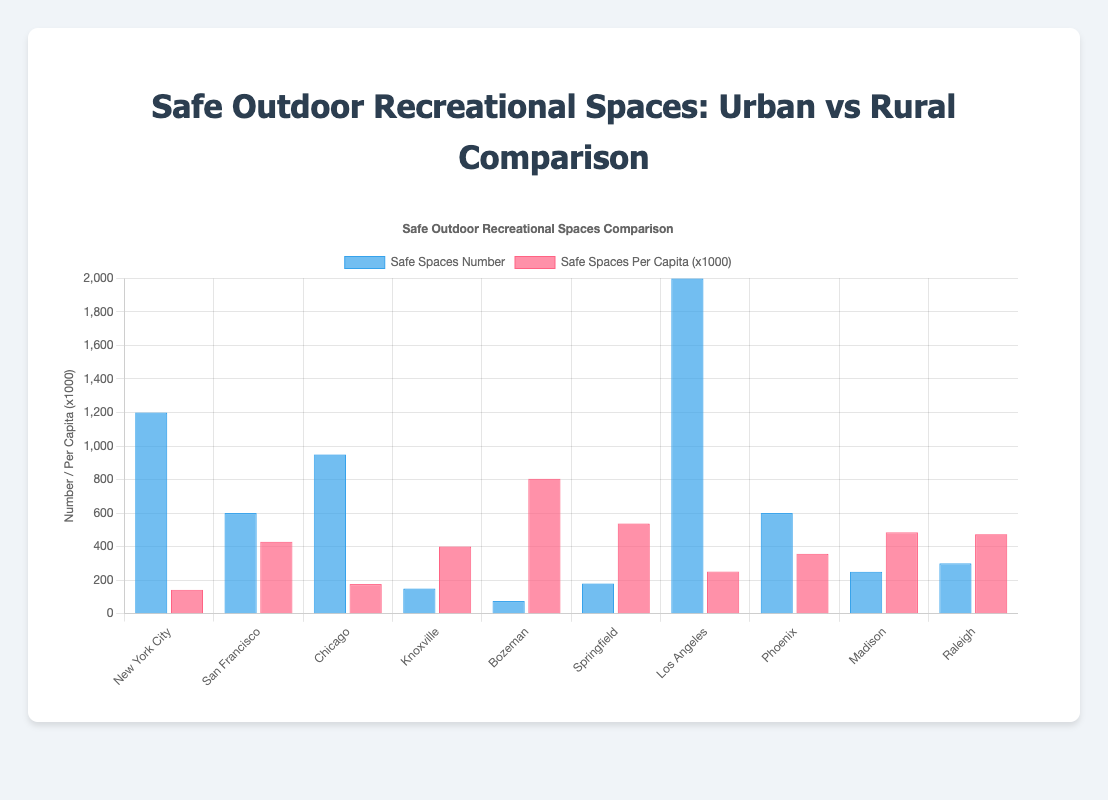What city has the highest number of safe spaces? The highest bar in the "Safe Spaces Number" dataset indicates the city with the highest number of safe spaces.
Answer: Los Angeles Which city has the lowest safe spaces per capita? The smallest bar in the "Safe Spaces Per Capita (x1000)" dataset indicates the city with the lowest safe spaces per capita.
Answer: New York City How do the safe spaces per capita in rural areas compare to those in urban areas? Grouping the cities by their region (Urban vs Rural) and averaging the safe spaces per capita values within each group will give a comparison.
Answer: Higher in rural areas How does San Francisco compare to New York City in terms of safe spaces per capita? Compare the height of the bars in the "Safe Spaces Per Capita (x1000)" dataset for San Francisco and New York City.
Answer: Higher in San Francisco Which rural city has the most and least number of safe spaces? Identify the tallest and shortest bars in the "Safe Spaces Number" dataset among rural cities (Knoxville, Bozeman, Springfield, Madison, Raleigh).
Answer: Most: Raleigh, Least: Bozeman What city has the greatest difference between safe spaces number and safe spaces per capita? Calculate the difference between the corresponding bars for each city and identify the city with the greatest difference.
Answer: New York City Which urban city has the highest safe spaces per capita? Compare the heights of the bars in the "Safe Spaces Per Capita (x1000)" dataset among urban cities and identify the highest bar.
Answer: San Francisco Compare the total number of safe spaces available in urban versus rural areas. Sum the "Safe Spaces Number" values for urban areas and rural areas, then compare these sums.
Answer: Urban: 5350, Rural: 955 Among urban areas, which city has the highest ratio of safe spaces number to total population? Calculate the ratio of "Safe Spaces Number" to "Total Population" for each urban city and identify the highest ratio.
Answer: San Francisco What is the overall trend in safe spaces availability comparing urban and rural areas? Observe the average heights of bars in both datasets (Safe Spaces Number and Safe Spaces Per Capita) for urban and rural areas to identify any general trends.
Answer: Rural areas have fewer safe spaces but higher per capita rates 